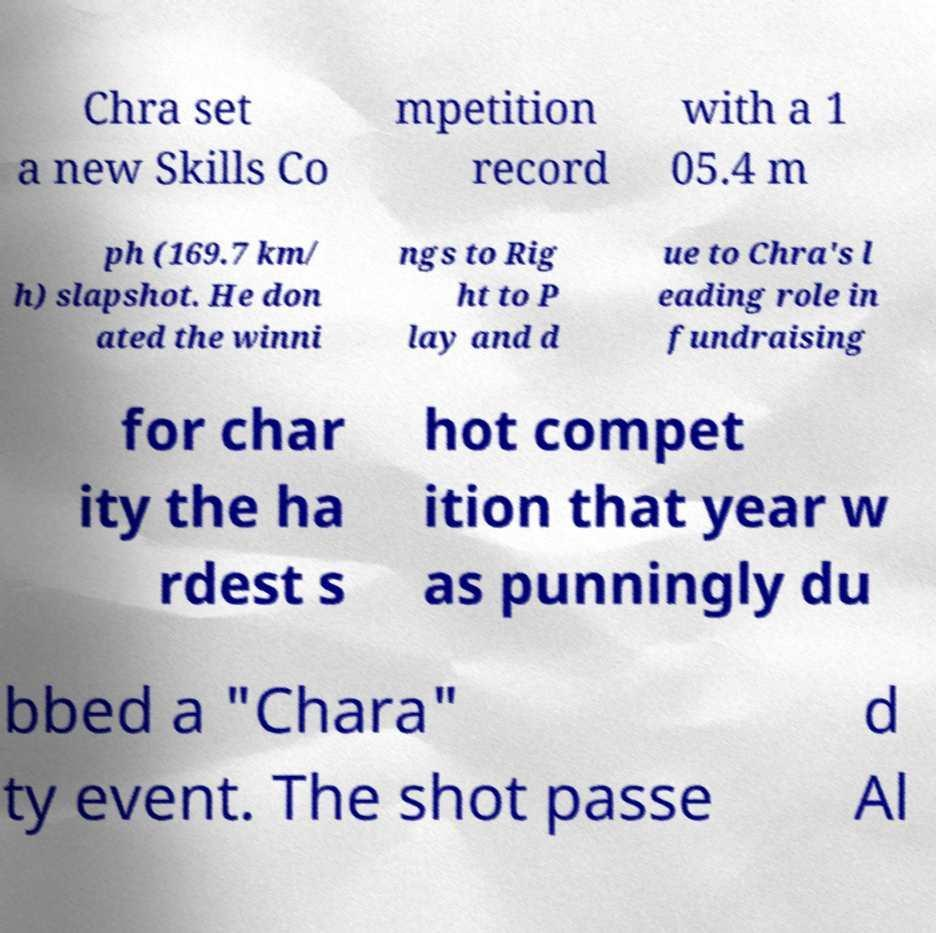Could you extract and type out the text from this image? Chra set a new Skills Co mpetition record with a 1 05.4 m ph (169.7 km/ h) slapshot. He don ated the winni ngs to Rig ht to P lay and d ue to Chra's l eading role in fundraising for char ity the ha rdest s hot compet ition that year w as punningly du bbed a "Chara" ty event. The shot passe d Al 